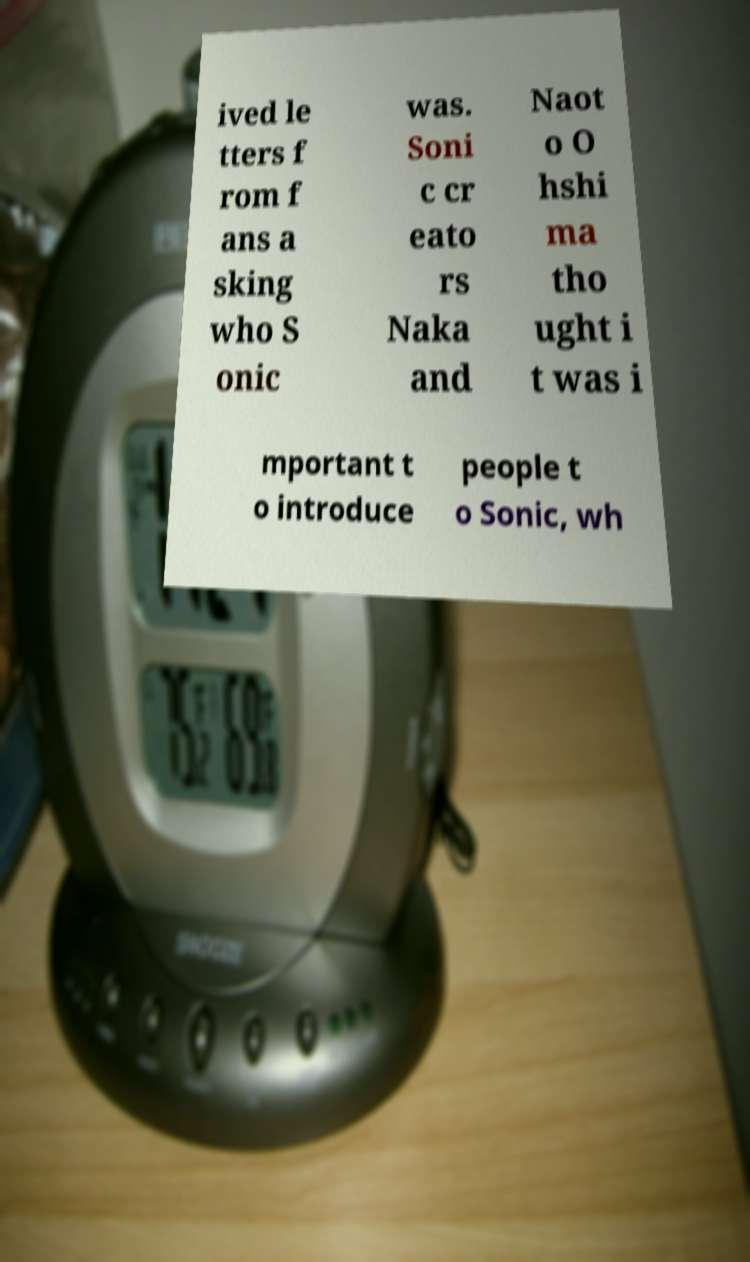I need the written content from this picture converted into text. Can you do that? ived le tters f rom f ans a sking who S onic was. Soni c cr eato rs Naka and Naot o O hshi ma tho ught i t was i mportant t o introduce people t o Sonic, wh 